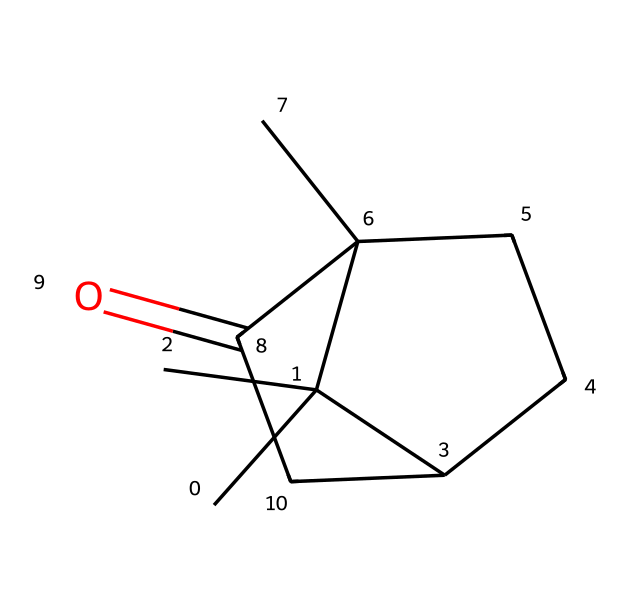What is the molecular formula for camphor? By analyzing the provided SMILES representation, we can identify the number of carbon (C), hydrogen (H), and oxygen (O) atoms. The structure CC1(C)C2CCC1(C)C(=O)C2 indicates there are 10 carbons, 16 hydrogens, and 1 oxygen. Therefore, the molecular formula can be summarized as C10H16O.
Answer: C10H16O How many rings are present in camphor? The structure includes two interconnected cycloalkane rings. The presence of the rings can be confirmed by observing the cyclic structure indicated by the numbers in the SMILES representation.
Answer: 2 What functional group is present in camphor? In the SMILES representation, there is a "C(=O)" which shows that there is a carbonyl group (C=O). This is typical for ketones, indicating that camphor contains a ketone functional group.
Answer: ketone What type of compound is camphor classified as? Analyzing the structure reveals that camphor has a cyclic nature (involving rings) and contains a carbonyl group, placing it in the category of cyclic ketones.
Answer: cyclic ketone How many hydrogen atoms are connected to the carbonyl carbon? In the structure, the carbonyl carbon is represented as C(=O), which means it has no hydrogen atoms directly connected to it because it's a double bond with oxygen. This indicates that the carbon atom of the carbonyl group is fully bonded.
Answer: 0 What is the total number of non-hydrogen atoms in camphor? Counting the total atoms from the molecular formula C10H16O, we have 10 carbon atoms and 1 oxygen atom. There are no other non-hydrogen atoms mentioned, so the total is 11.
Answer: 11 